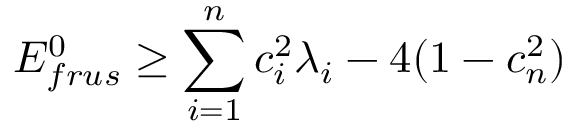<formula> <loc_0><loc_0><loc_500><loc_500>E _ { f r u s } ^ { 0 } \geq \sum _ { i = 1 } ^ { n } c _ { i } ^ { 2 } \lambda _ { i } - 4 ( 1 - c _ { n } ^ { 2 } )</formula> 